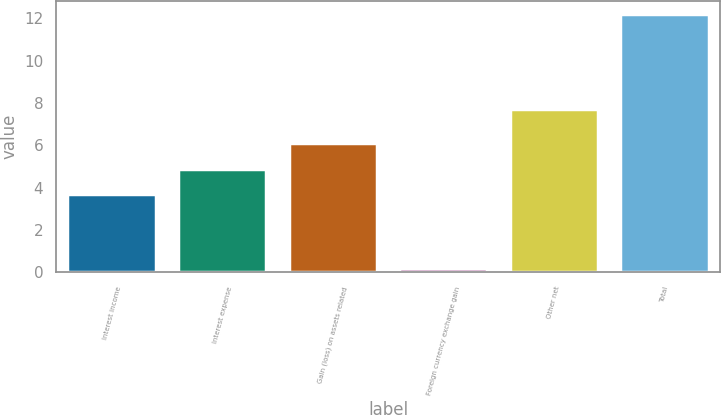<chart> <loc_0><loc_0><loc_500><loc_500><bar_chart><fcel>Interest income<fcel>Interest expense<fcel>Gain (loss) on assets related<fcel>Foreign currency exchange gain<fcel>Other net<fcel>Total<nl><fcel>3.7<fcel>4.9<fcel>6.1<fcel>0.2<fcel>7.7<fcel>12.2<nl></chart> 